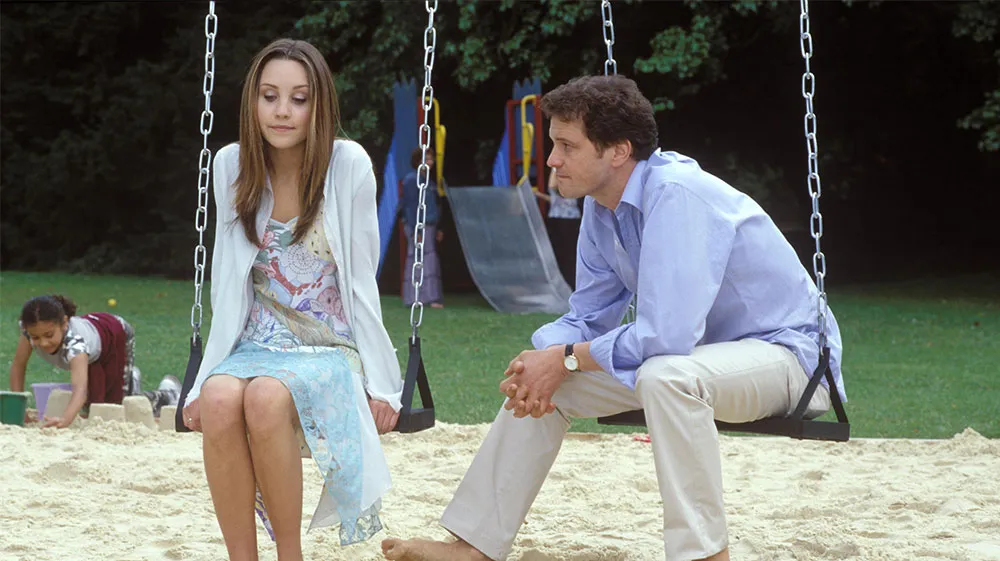Describe the mood of the scene and how do the expressions of the individuals contribute to it? The overall mood of the scene is contemplative and serene, underscored by the soft, natural lighting and the quiet background activity. The woman's expression, which is thoughtful and reserved, along with the man's attentive and calm demeanor, contribute to a sense of earnest communication or reflection. Their expressions and body language suggest a moment of meaningful connection or introspective dialogue, enhancing the peaceful yet emotionally charged atmosphere of the setting. 